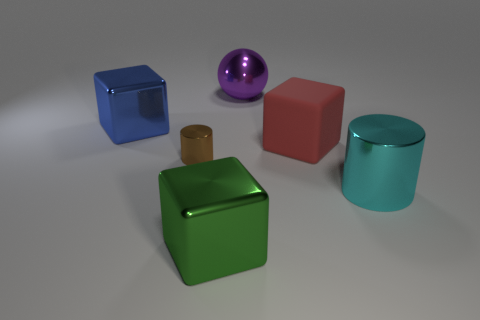Are there any large rubber blocks to the right of the large purple ball?
Offer a very short reply. Yes. How big is the shiny cylinder that is to the left of the cube that is right of the green shiny object?
Keep it short and to the point. Small. Are there the same number of big red rubber objects left of the purple sphere and shiny objects on the left side of the big blue object?
Your answer should be very brief. Yes. There is a cube that is in front of the rubber thing; are there any green metal things that are left of it?
Provide a short and direct response. No. How many large green cubes are right of the big metal thing that is in front of the large metal object that is to the right of the large purple metallic sphere?
Make the answer very short. 0. Is the number of tiny green metallic cylinders less than the number of cyan shiny cylinders?
Give a very brief answer. Yes. There is a thing in front of the cyan metal cylinder; is its shape the same as the rubber object in front of the big purple thing?
Offer a very short reply. Yes. What color is the matte object?
Your answer should be compact. Red. What number of rubber things are either red things or large purple spheres?
Give a very brief answer. 1. What color is the other big matte object that is the same shape as the big blue thing?
Your response must be concise. Red. 